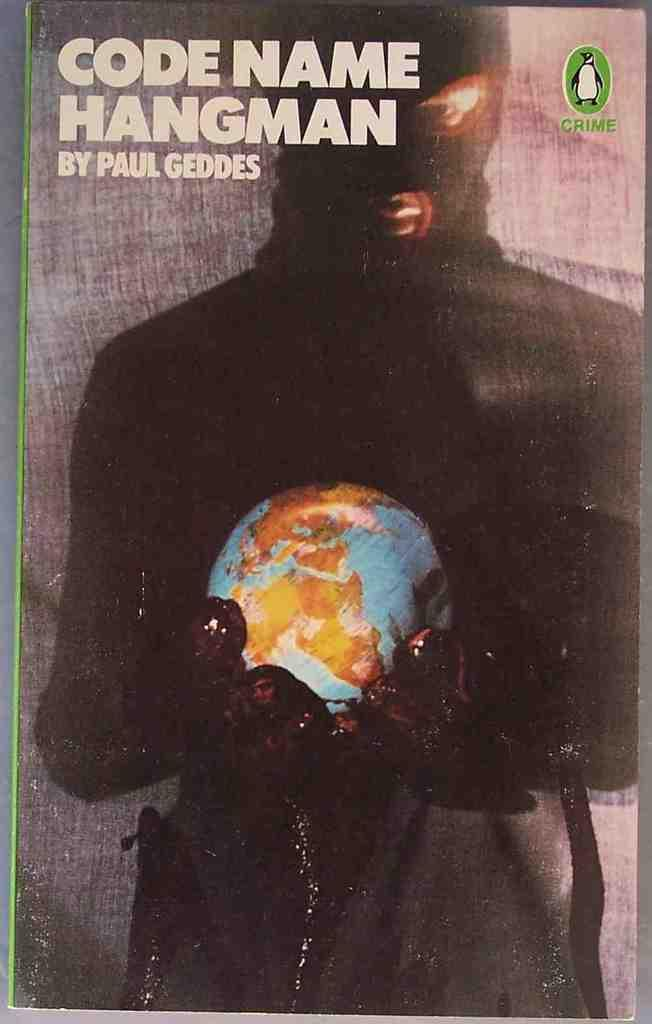Provide a one-sentence caption for the provided image. Paul Geddes wrote a book called Code Name Hangman. 